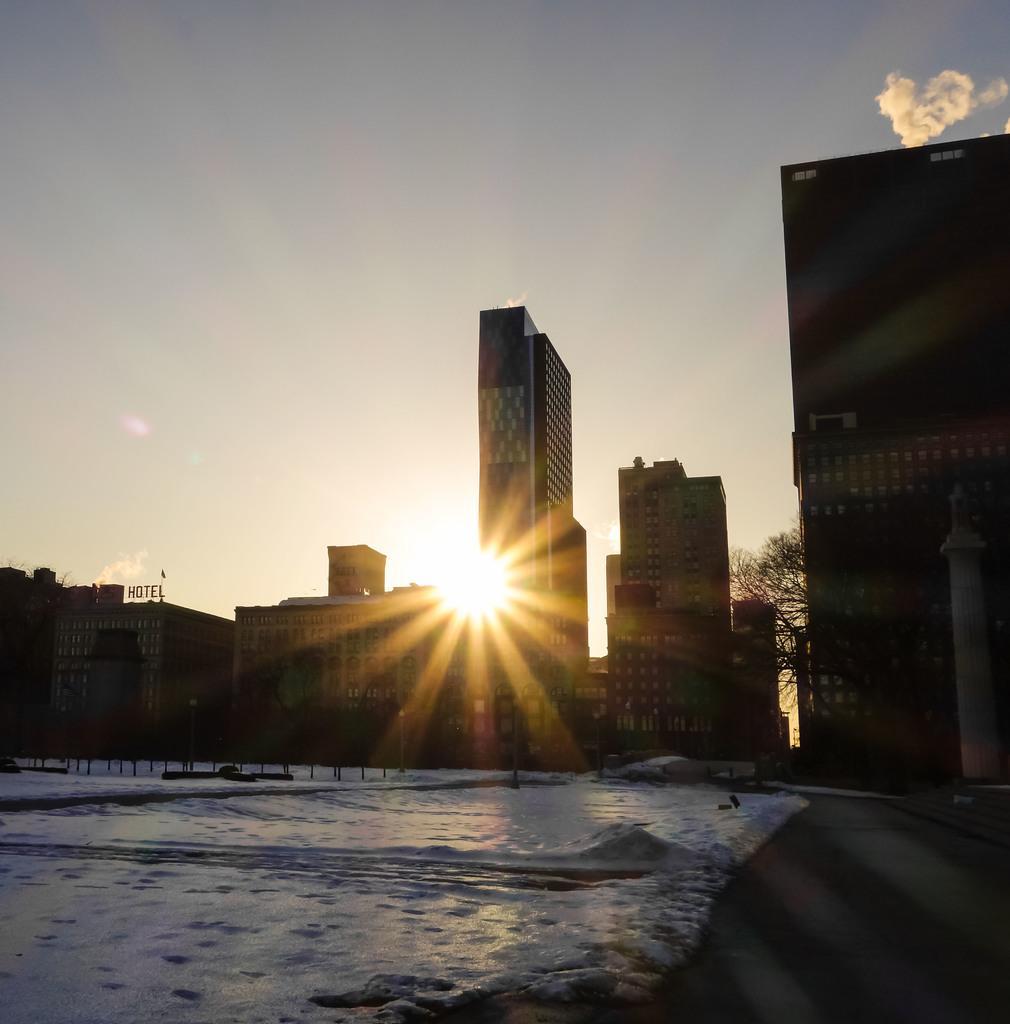In one or two sentences, can you explain what this image depicts? This image consists of buildings. At the bottom, there is snow. In the background, we can see the sun in the sky. 